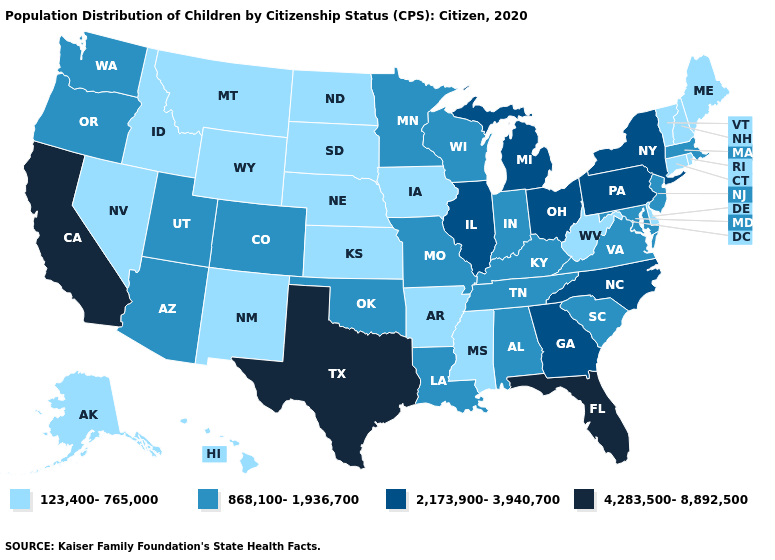Name the states that have a value in the range 4,283,500-8,892,500?
Concise answer only. California, Florida, Texas. What is the lowest value in the MidWest?
Concise answer only. 123,400-765,000. Which states have the lowest value in the West?
Quick response, please. Alaska, Hawaii, Idaho, Montana, Nevada, New Mexico, Wyoming. What is the lowest value in states that border Mississippi?
Concise answer only. 123,400-765,000. Does Illinois have the highest value in the MidWest?
Be succinct. Yes. What is the value of Hawaii?
Concise answer only. 123,400-765,000. What is the lowest value in the MidWest?
Be succinct. 123,400-765,000. Does Montana have the lowest value in the USA?
Give a very brief answer. Yes. Does South Carolina have a lower value than Tennessee?
Keep it brief. No. Does Georgia have the lowest value in the USA?
Answer briefly. No. What is the value of Ohio?
Be succinct. 2,173,900-3,940,700. What is the lowest value in the Northeast?
Be succinct. 123,400-765,000. What is the value of Kansas?
Keep it brief. 123,400-765,000. Name the states that have a value in the range 2,173,900-3,940,700?
Concise answer only. Georgia, Illinois, Michigan, New York, North Carolina, Ohio, Pennsylvania. What is the value of Ohio?
Write a very short answer. 2,173,900-3,940,700. 